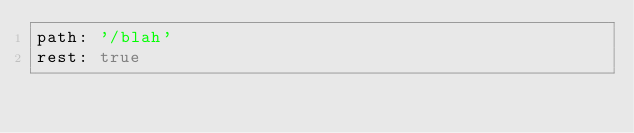<code> <loc_0><loc_0><loc_500><loc_500><_YAML_>path: '/blah'
rest: true
</code> 